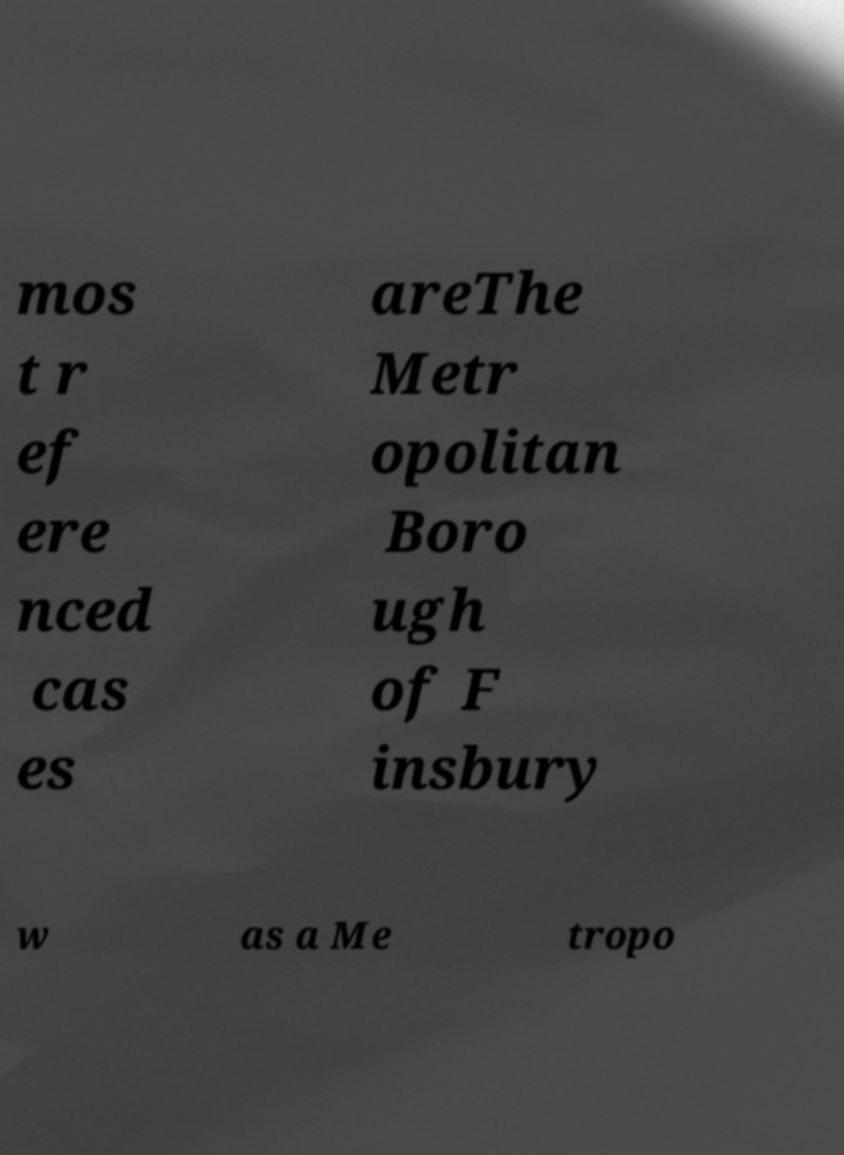Could you extract and type out the text from this image? mos t r ef ere nced cas es areThe Metr opolitan Boro ugh of F insbury w as a Me tropo 